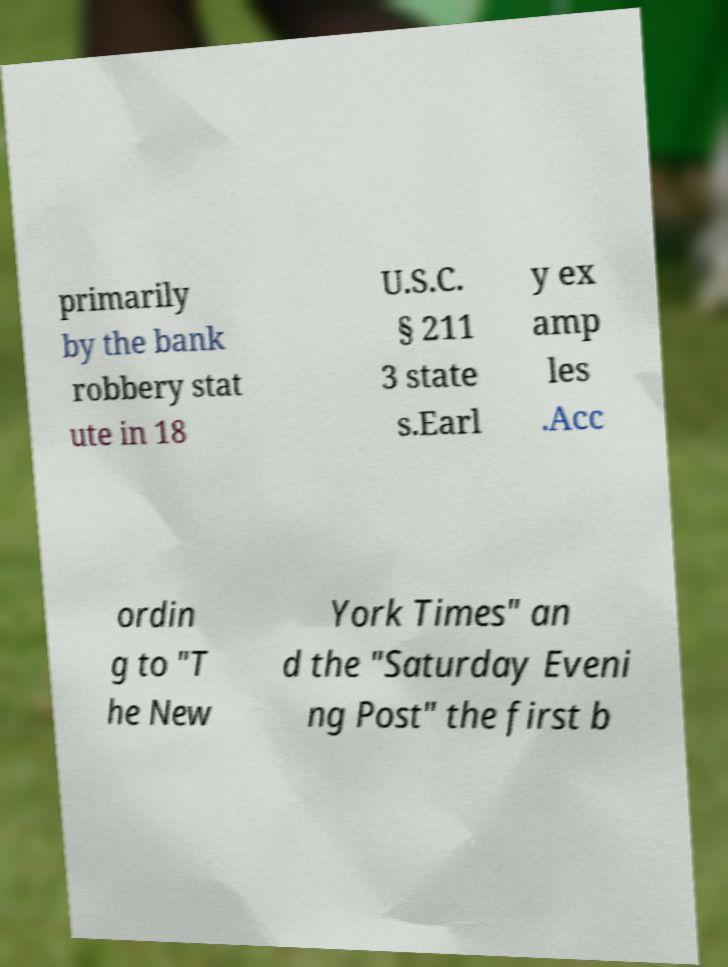Could you extract and type out the text from this image? primarily by the bank robbery stat ute in 18 U.S.C. § 211 3 state s.Earl y ex amp les .Acc ordin g to "T he New York Times" an d the "Saturday Eveni ng Post" the first b 